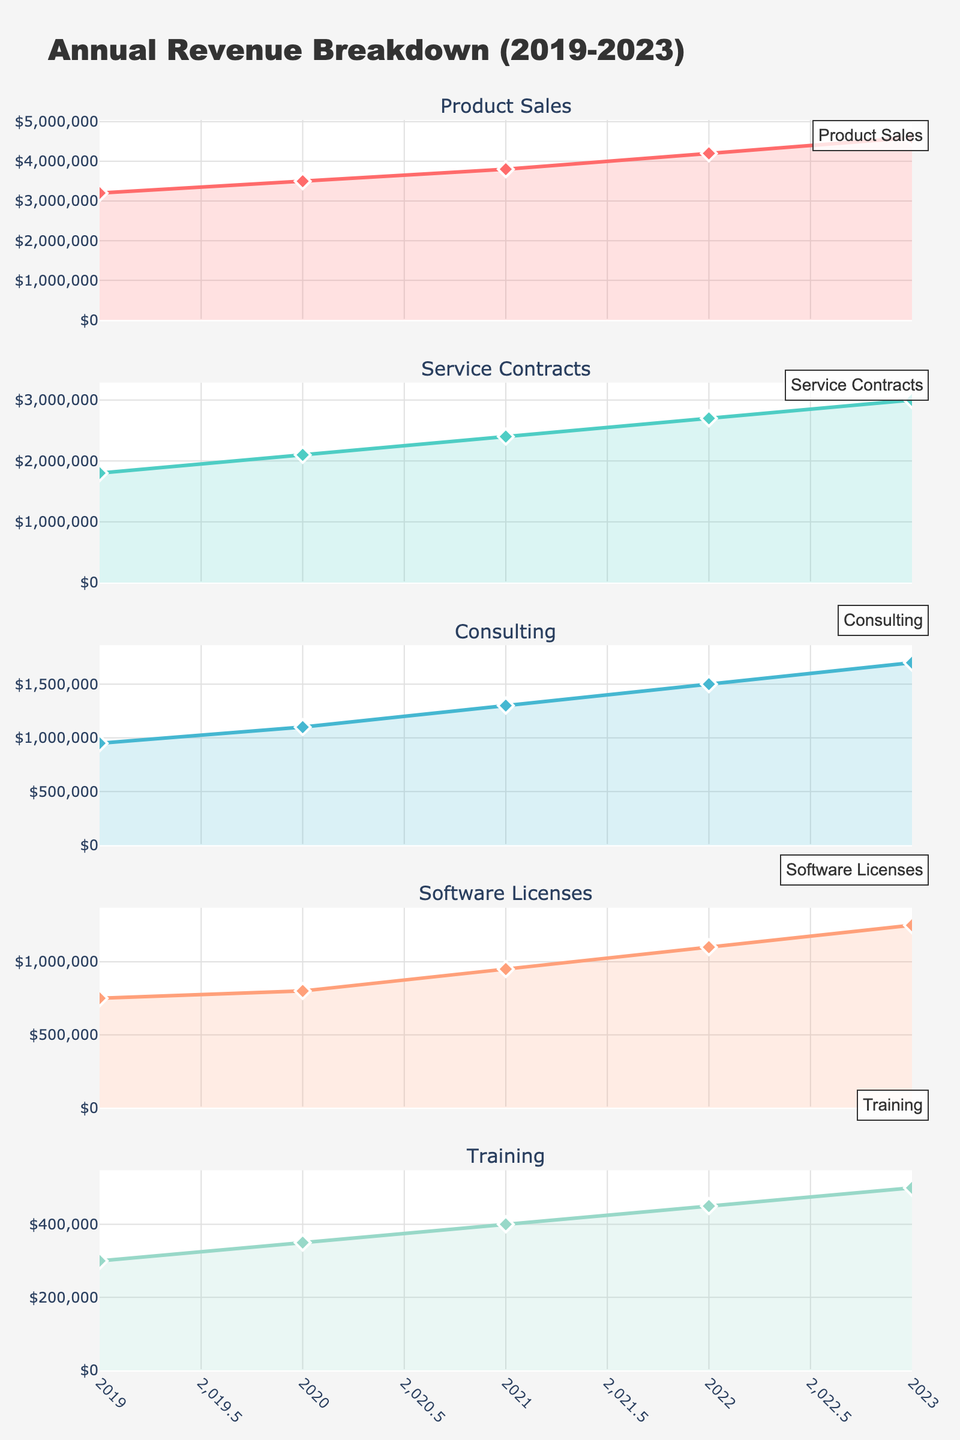Which product category saw the highest revenue in 2023? Review the 'Annual Revenue Breakdown (2019-2023)' title and locate the subplot for 2023 to identify which line reaches the highest point.
Answer: Product Sales How did the revenue from Consulting change from 2019 to 2023? Identify the Consulting subplot and compare the points at 2019 and 2023. Consulting revenue increased from 950,000 to 1,700,000.
Answer: Increased Which category had the most consistent increase in revenue over the 5 years? Analyze all subplots and observe the trend lines for each. The line for Product Sales consistently trends upward all 5 years.
Answer: Product Sales What's the total revenue from Software Licenses and Training in 2022? Locate the 2022 markers for 'Software Licenses' and 'Training' subplots; sum up 1,100,000 and 450,000.
Answer: 1,550,000 Which year had the smallest gap between Product Sales and Service Contracts revenue? Calculate the difference between Product Sales and Service Contracts for each year, and identify the smallest gap
Answer: 2020 In which year did Training revenue first reach 400,000? Identify the Training subplot and locate the first year when the revenue data point reaches or exceeds 400,000.
Answer: 2021 Which product category grew the most between 2022 and 2023? Compare revenue differences for all categories between 2022 and 2023. Product Sales increased from 4,200,000 to 4,600,000, the highest growth.
Answer: Product Sales What is the average annual revenue from Service Contracts over the 5 years? Sum Service Contracts revenue from all years and divide by 5. The total is 1,800,000 + 2,100,000 + 2,400,000 + 2,700,000 + 3,000,000 = 12,000,000. The average is 12,000,000 / 5.
Answer: 2,400,000 